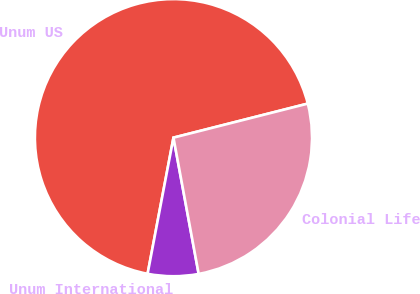Convert chart. <chart><loc_0><loc_0><loc_500><loc_500><pie_chart><fcel>Unum US<fcel>Unum International<fcel>Colonial Life<nl><fcel>68.06%<fcel>5.9%<fcel>26.04%<nl></chart> 